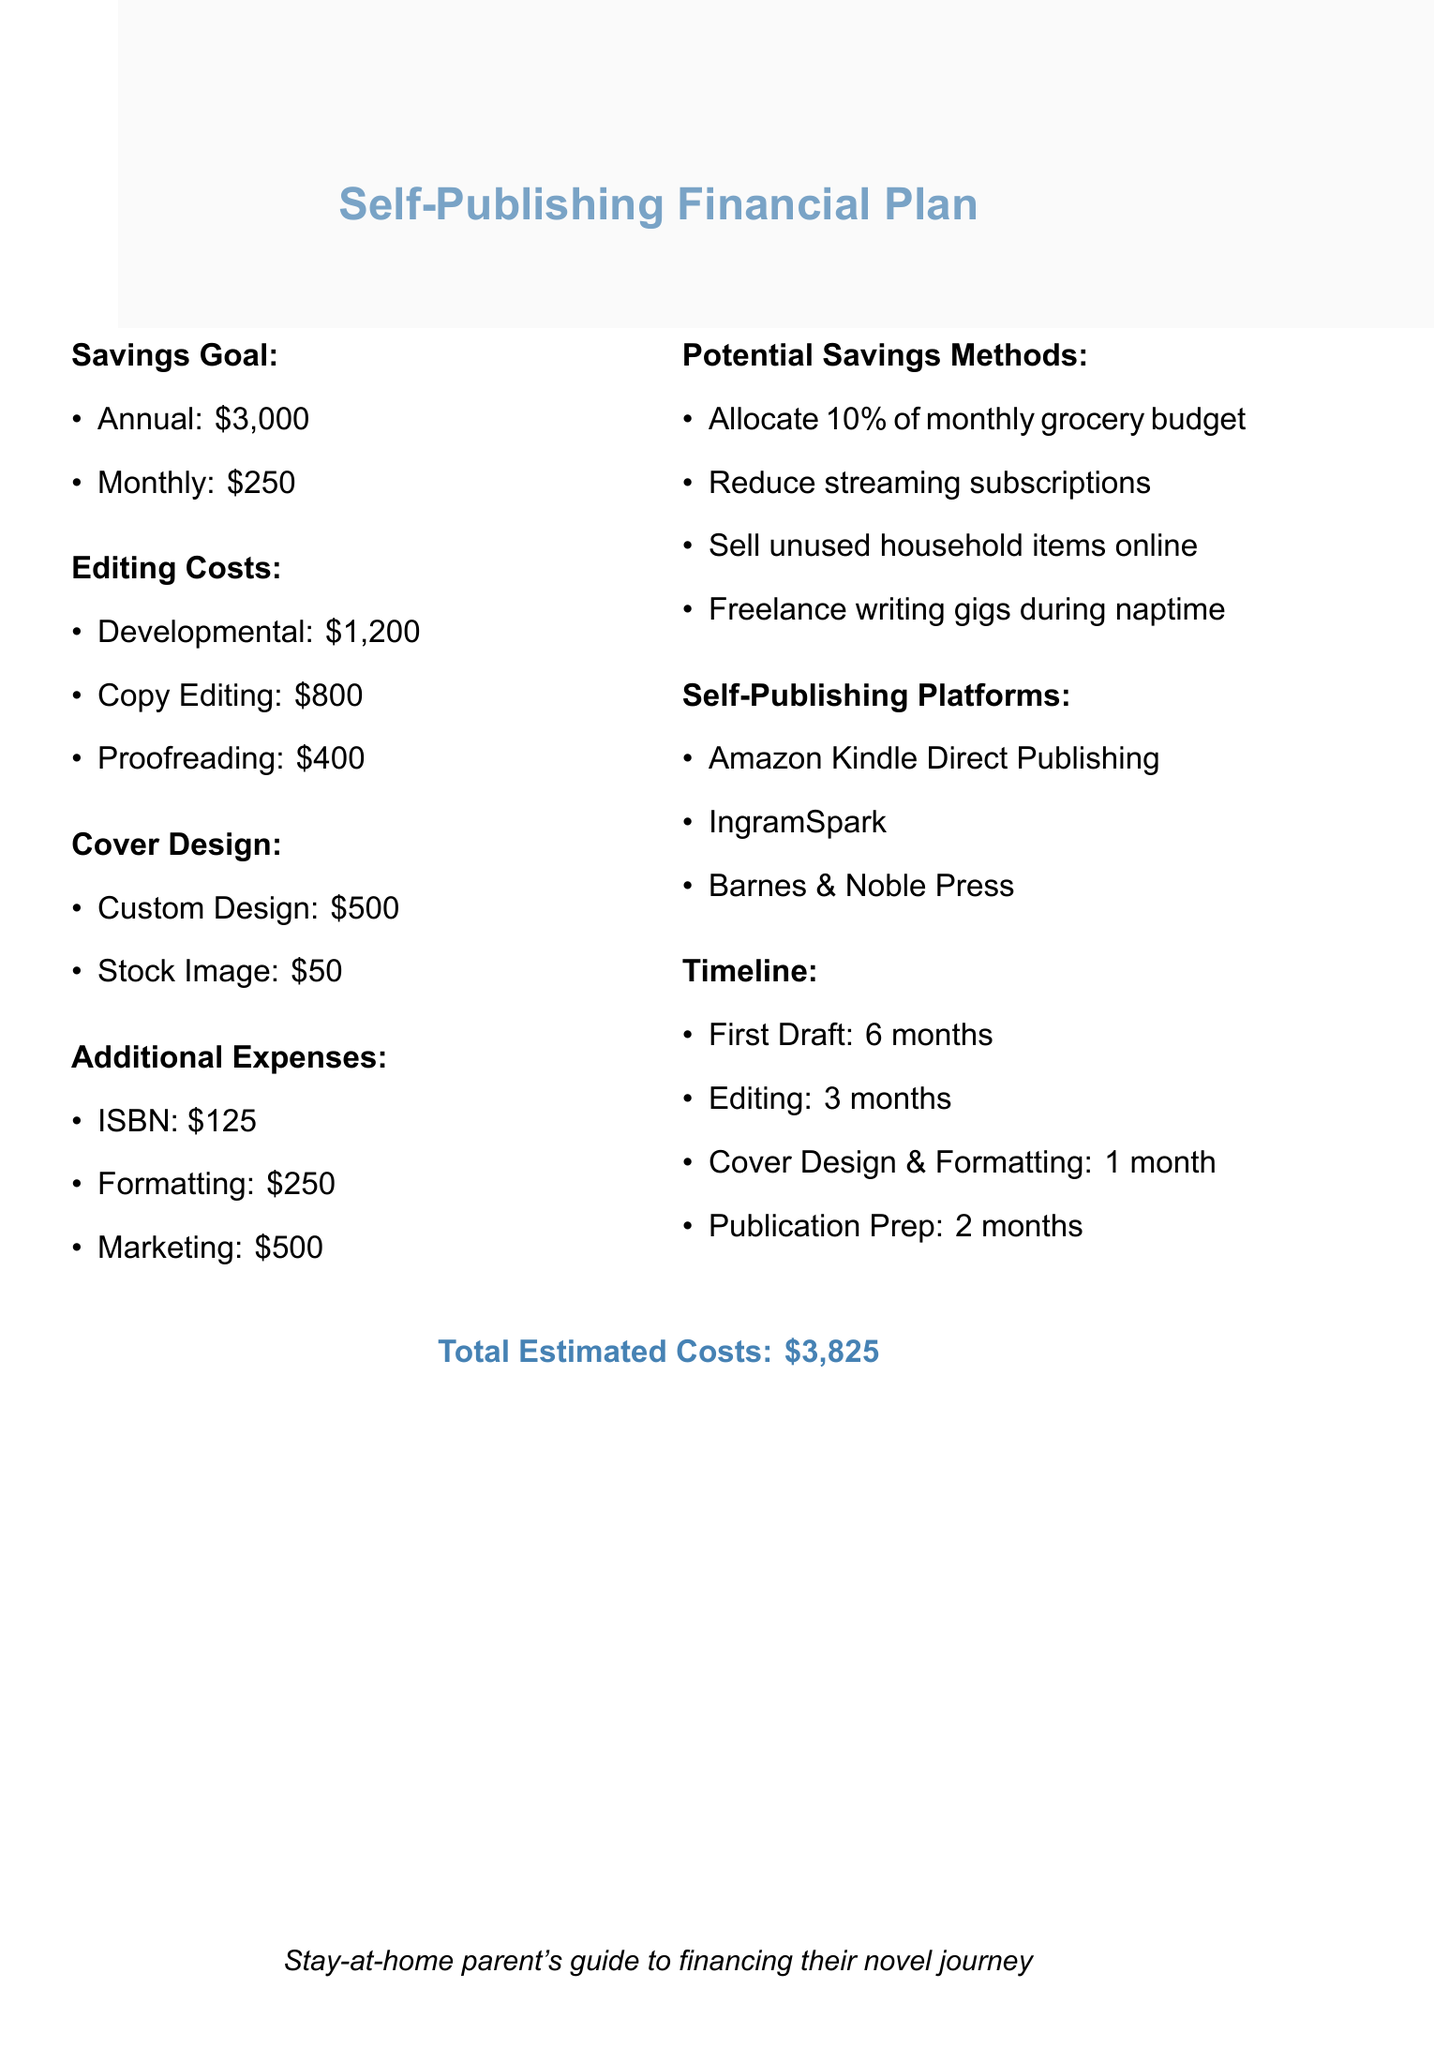What is the annual savings goal? The annual savings goal is explicitly stated in the document.
Answer: $3,000 What are the monthly savings targets? The monthly savings target is specified alongside the annual goal in the document.
Answer: $250 What is the cost of developmental editing? The cost of developmental editing is noted under the editing costs section.
Answer: $1,200 What is the total estimated cost of self-publishing? The total estimated costs are mentioned at the end of the document.
Answer: $3,825 How long is the editing process? The duration is listed in the timeline section of the document.
Answer: 3 months What percentage of the grocery budget should be allocated for savings? The document suggests a specific percentage as a savings method.
Answer: 10% Which self-publishing platform is mentioned first? The sequence of platforms is provided in the self-publishing platforms section.
Answer: Amazon Kindle Direct Publishing What is the budget for marketing? The budget for marketing is included in the additional expenses.
Answer: $500 What is the total cost of cover design? The total cost of cover design can be calculated from the details in the cover design costs section.
Answer: $550 